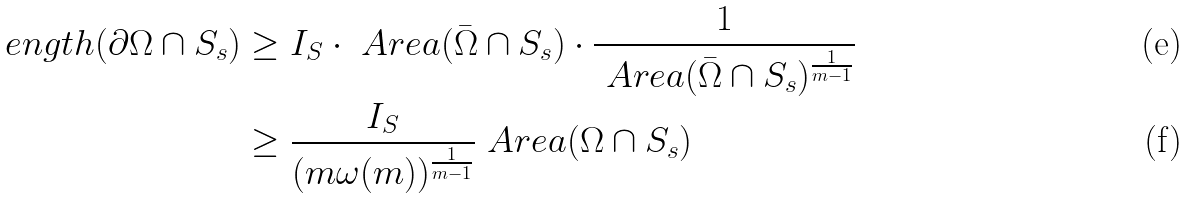<formula> <loc_0><loc_0><loc_500><loc_500>\L e n g t h ( \partial \Omega \cap S _ { s } ) & \geq I _ { S } \cdot \ A r e a ( \bar { \Omega } \cap S _ { s } ) \cdot \frac { 1 } { \ A r e a ( \bar { \Omega } \cap S _ { s } ) ^ { \frac { 1 } { m - 1 } } } \\ & \geq \frac { I _ { S } } { ( m \omega ( m ) ) ^ { \frac { 1 } { m - 1 } } } \ A r e a ( \Omega \cap S _ { s } )</formula> 